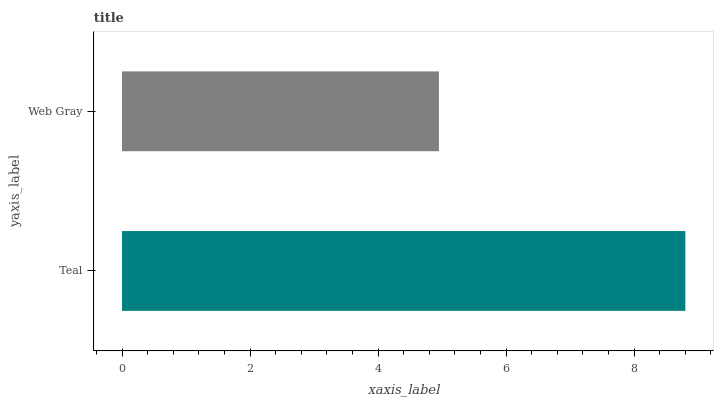Is Web Gray the minimum?
Answer yes or no. Yes. Is Teal the maximum?
Answer yes or no. Yes. Is Web Gray the maximum?
Answer yes or no. No. Is Teal greater than Web Gray?
Answer yes or no. Yes. Is Web Gray less than Teal?
Answer yes or no. Yes. Is Web Gray greater than Teal?
Answer yes or no. No. Is Teal less than Web Gray?
Answer yes or no. No. Is Teal the high median?
Answer yes or no. Yes. Is Web Gray the low median?
Answer yes or no. Yes. Is Web Gray the high median?
Answer yes or no. No. Is Teal the low median?
Answer yes or no. No. 